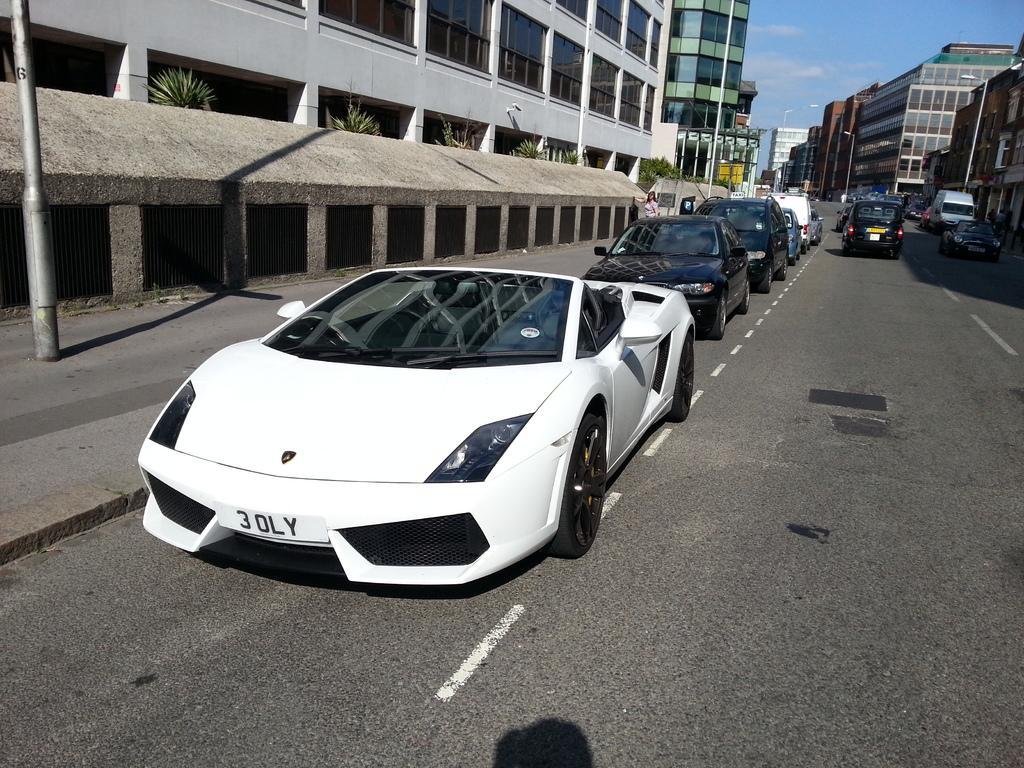In one or two sentences, can you explain what this image depicts? In this picture we can observe some cars on the road. There are some buildings. In the background there is a sky. 